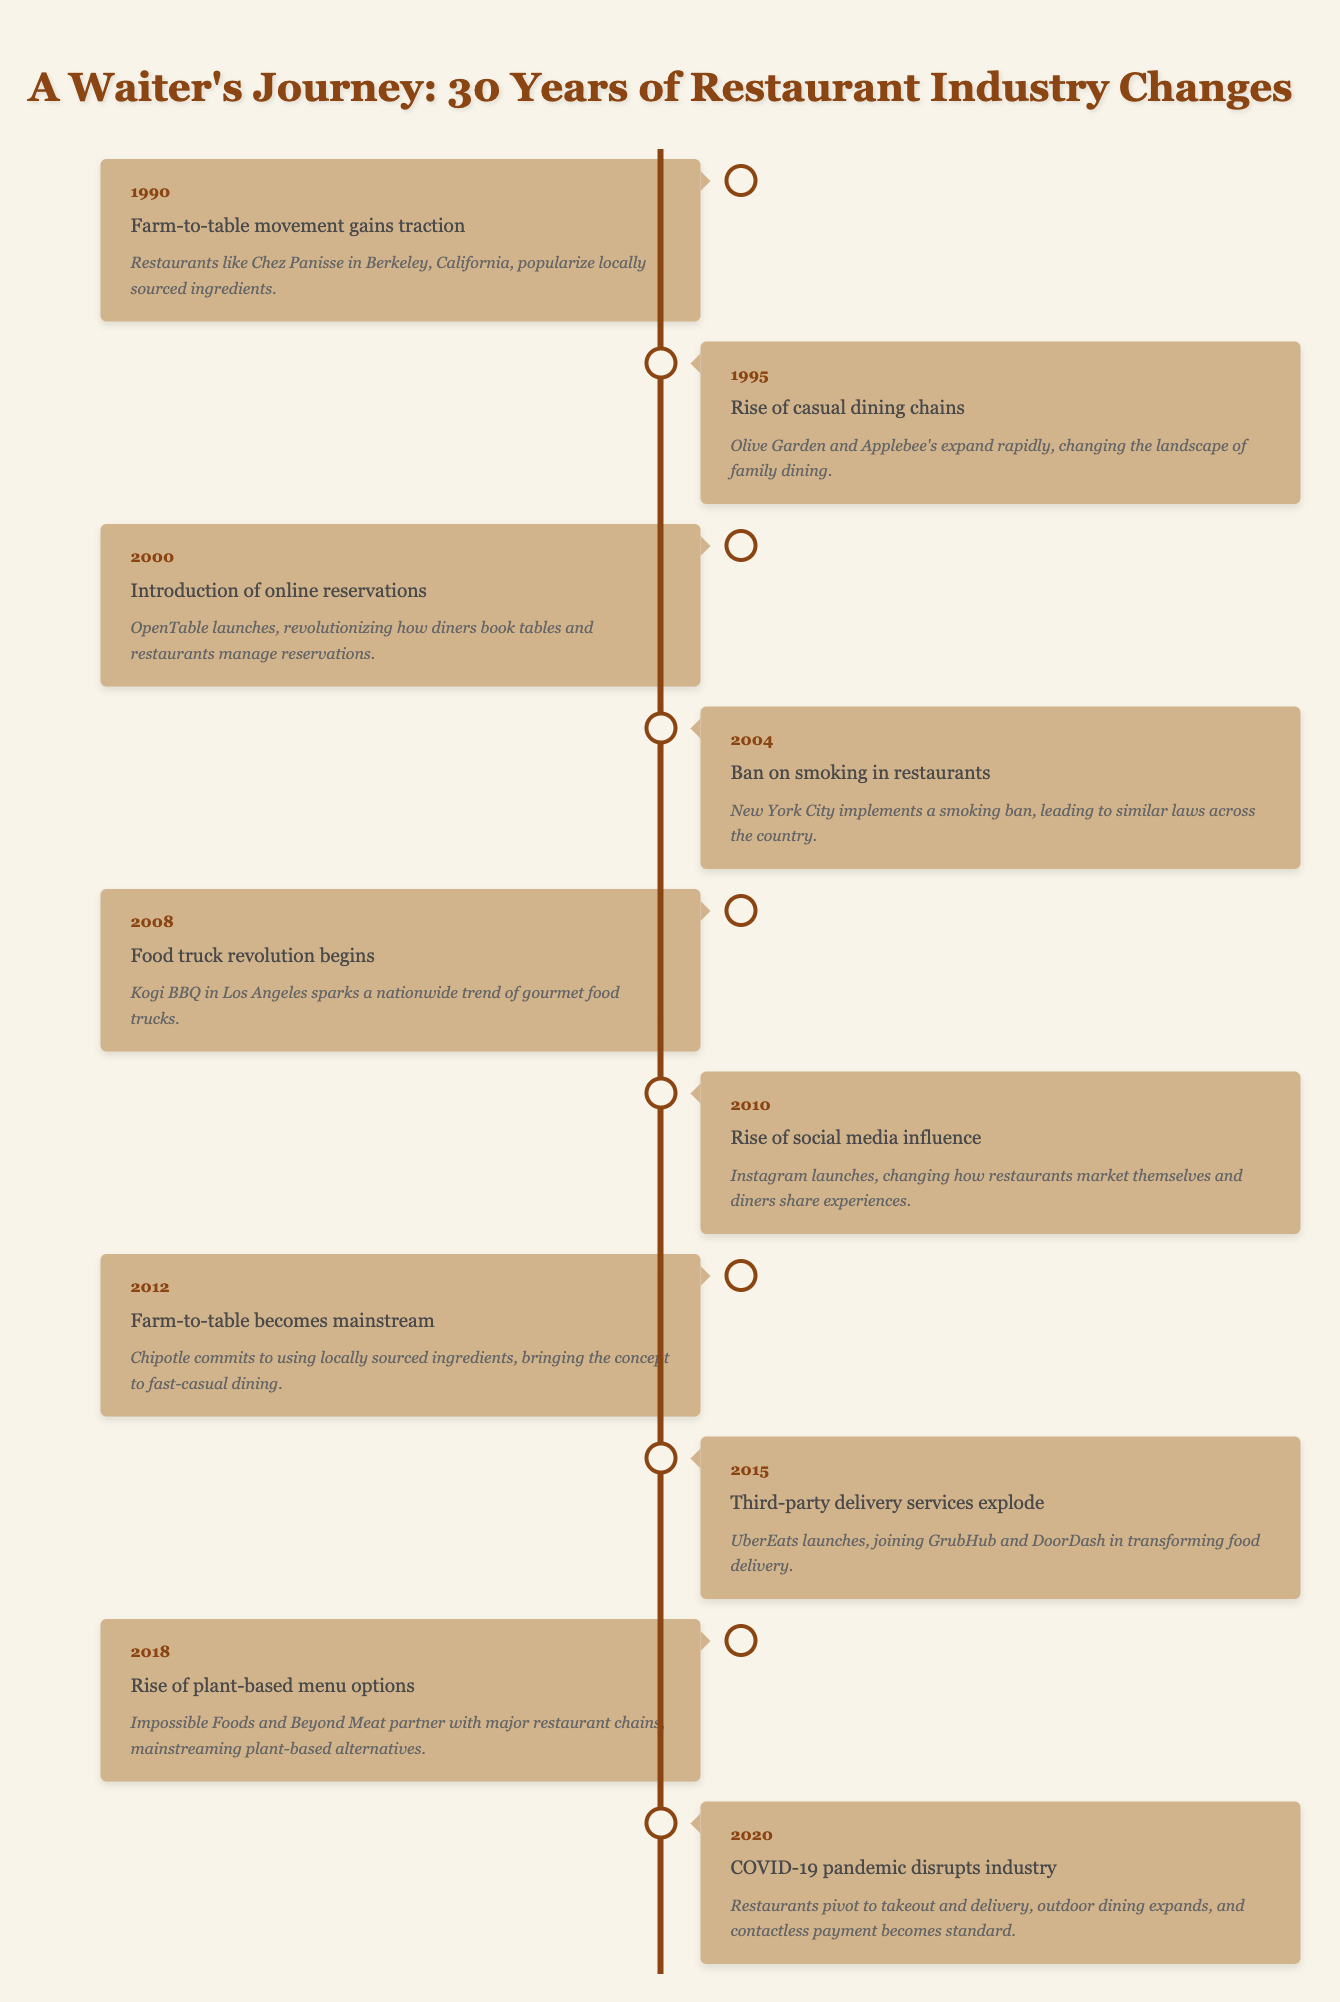What major movement began gaining traction in 1990? According to the timeline, the Farm-to-table movement gained traction in 1990. This event highlights the rise of interest in locally sourced ingredients in restaurants.
Answer: Farm-to-table movement gains traction Which event required restaurants to change their policies regarding smoking? The timeline indicates that a ban on smoking in restaurants was implemented in 2004, notably starting from New York City and leading to similar laws across the country.
Answer: Ban on smoking in restaurants In what year did the food truck revolution start? The timeline states that the food truck revolution began in 2008, with Kogi BBQ in Los Angeles being a key player in sparking this trend.
Answer: 2008 How many years passed between the introduction of online reservations and the rise of social media influence? The introduction of online reservations occurred in 2000 and the rise of social media influence happened in 2010. Therefore, the difference is 2010 - 2000 = 10 years.
Answer: 10 years Was the Farm-to-table concept considered mainstream before 2012? The timeline outlines that in 2012, the Farm-to-table concept became mainstream, and therefore it was not considered mainstream before that year.
Answer: No Which year saw the launch of third-party delivery services? According to the timeline, the year 2015 marked the explosion of third-party delivery services, specifically mentioning UberEats, GrubHub, and DoorDash joining the trend.
Answer: 2015 In the years indicated, what was significant about the year 2020 for the restaurant industry? The timeline notes that 2020 was disrupted by the COVID-19 pandemic, leading to a pivot in dining strategies, including an increase in takeout and delivery options and contactless payment becoming standard.
Answer: COVID-19 pandemic disrupts industry How many distinct events related to food sourcing can you find in this timeline? The timeline lists two distinct events related to food sourcing: the Farm-to-table movement gaining traction in 1990 and it becoming mainstream in 2012. This indicates a focus on locally sourced ingredients over two decades.
Answer: 2 events What was the first occurrence mentioned regarding plant-based menu options? In 2018, the rise of plant-based menu options is highlighted, with Impossible Foods and Beyond Meat partnering with major restaurant chains to mainstream these alternatives.
Answer: 2018 